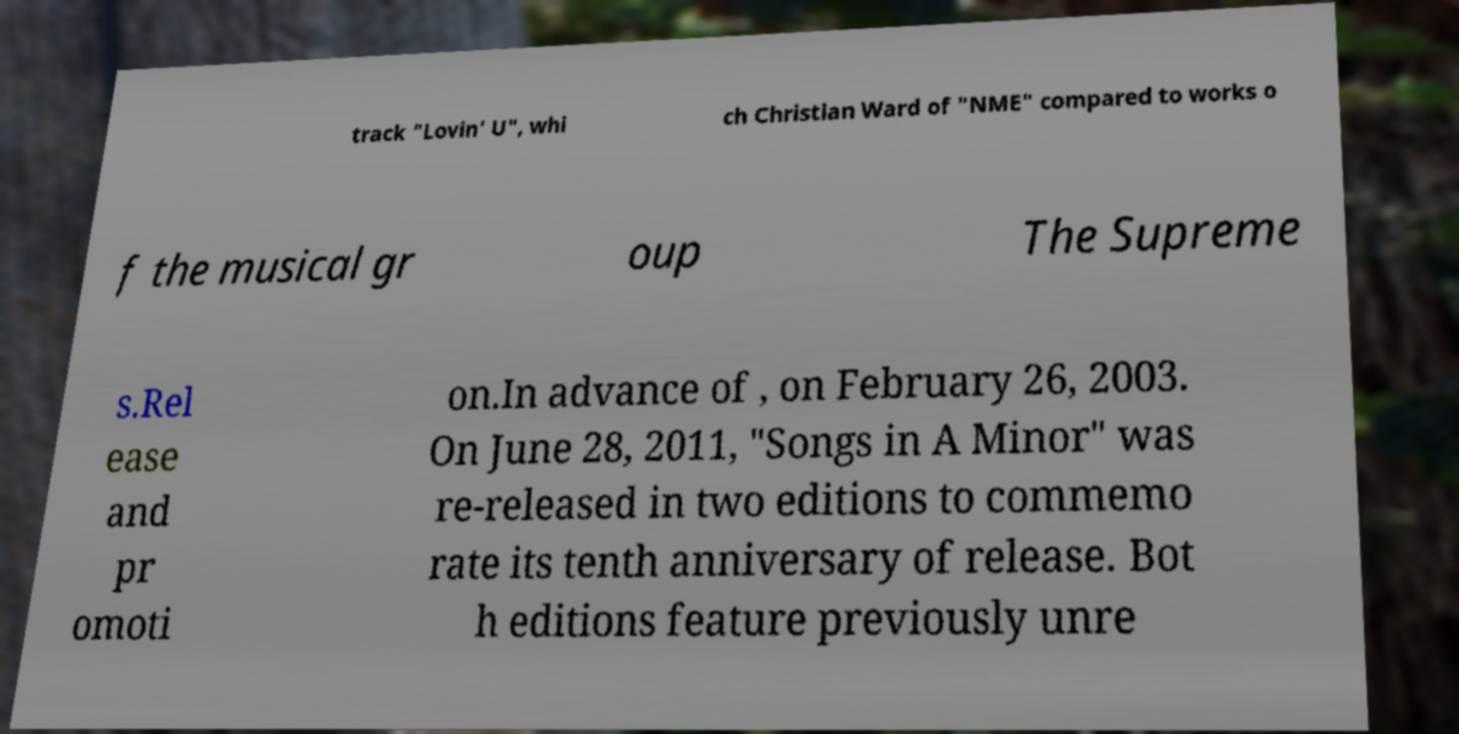Could you extract and type out the text from this image? track "Lovin' U", whi ch Christian Ward of "NME" compared to works o f the musical gr oup The Supreme s.Rel ease and pr omoti on.In advance of , on February 26, 2003. On June 28, 2011, "Songs in A Minor" was re-released in two editions to commemo rate its tenth anniversary of release. Bot h editions feature previously unre 